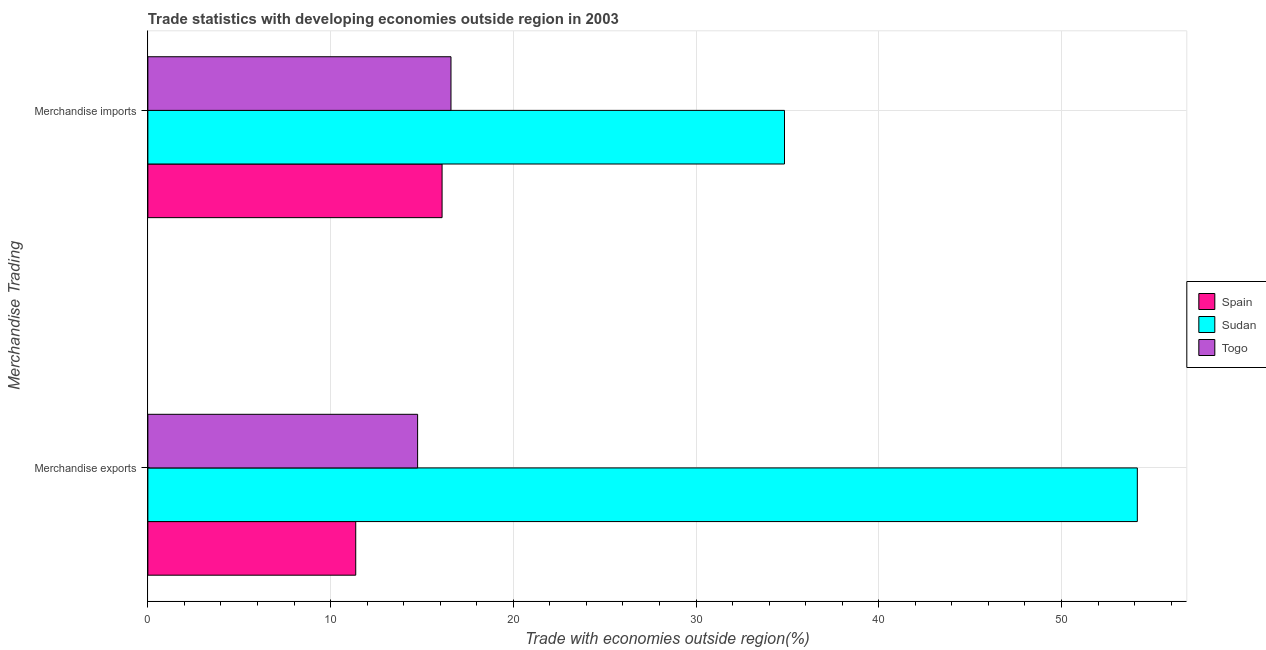How many different coloured bars are there?
Keep it short and to the point. 3. How many groups of bars are there?
Your answer should be compact. 2. How many bars are there on the 1st tick from the bottom?
Provide a short and direct response. 3. What is the label of the 1st group of bars from the top?
Provide a short and direct response. Merchandise imports. What is the merchandise imports in Spain?
Your response must be concise. 16.1. Across all countries, what is the maximum merchandise exports?
Provide a succinct answer. 54.15. Across all countries, what is the minimum merchandise exports?
Your response must be concise. 11.38. In which country was the merchandise imports maximum?
Make the answer very short. Sudan. What is the total merchandise imports in the graph?
Provide a short and direct response. 67.53. What is the difference between the merchandise exports in Spain and that in Togo?
Give a very brief answer. -3.39. What is the difference between the merchandise exports in Spain and the merchandise imports in Togo?
Ensure brevity in your answer.  -5.21. What is the average merchandise imports per country?
Keep it short and to the point. 22.51. What is the difference between the merchandise exports and merchandise imports in Spain?
Give a very brief answer. -4.73. In how many countries, is the merchandise exports greater than 20 %?
Offer a terse response. 1. What is the ratio of the merchandise exports in Togo to that in Spain?
Keep it short and to the point. 1.3. In how many countries, is the merchandise exports greater than the average merchandise exports taken over all countries?
Offer a very short reply. 1. What does the 2nd bar from the top in Merchandise imports represents?
Give a very brief answer. Sudan. What does the 3rd bar from the bottom in Merchandise exports represents?
Make the answer very short. Togo. How many bars are there?
Provide a succinct answer. 6. Are all the bars in the graph horizontal?
Give a very brief answer. Yes. What is the difference between two consecutive major ticks on the X-axis?
Offer a terse response. 10. Does the graph contain grids?
Offer a terse response. Yes. Where does the legend appear in the graph?
Provide a short and direct response. Center right. How many legend labels are there?
Ensure brevity in your answer.  3. How are the legend labels stacked?
Offer a terse response. Vertical. What is the title of the graph?
Offer a terse response. Trade statistics with developing economies outside region in 2003. Does "Finland" appear as one of the legend labels in the graph?
Ensure brevity in your answer.  No. What is the label or title of the X-axis?
Provide a succinct answer. Trade with economies outside region(%). What is the label or title of the Y-axis?
Give a very brief answer. Merchandise Trading. What is the Trade with economies outside region(%) of Spain in Merchandise exports?
Your response must be concise. 11.38. What is the Trade with economies outside region(%) in Sudan in Merchandise exports?
Give a very brief answer. 54.15. What is the Trade with economies outside region(%) in Togo in Merchandise exports?
Offer a very short reply. 14.76. What is the Trade with economies outside region(%) of Spain in Merchandise imports?
Offer a very short reply. 16.1. What is the Trade with economies outside region(%) of Sudan in Merchandise imports?
Your response must be concise. 34.84. What is the Trade with economies outside region(%) in Togo in Merchandise imports?
Your answer should be compact. 16.59. Across all Merchandise Trading, what is the maximum Trade with economies outside region(%) in Spain?
Ensure brevity in your answer.  16.1. Across all Merchandise Trading, what is the maximum Trade with economies outside region(%) in Sudan?
Offer a terse response. 54.15. Across all Merchandise Trading, what is the maximum Trade with economies outside region(%) in Togo?
Give a very brief answer. 16.59. Across all Merchandise Trading, what is the minimum Trade with economies outside region(%) in Spain?
Offer a very short reply. 11.38. Across all Merchandise Trading, what is the minimum Trade with economies outside region(%) in Sudan?
Your answer should be very brief. 34.84. Across all Merchandise Trading, what is the minimum Trade with economies outside region(%) in Togo?
Make the answer very short. 14.76. What is the total Trade with economies outside region(%) of Spain in the graph?
Your answer should be compact. 27.48. What is the total Trade with economies outside region(%) in Sudan in the graph?
Offer a terse response. 88.99. What is the total Trade with economies outside region(%) of Togo in the graph?
Your answer should be very brief. 31.35. What is the difference between the Trade with economies outside region(%) of Spain in Merchandise exports and that in Merchandise imports?
Keep it short and to the point. -4.73. What is the difference between the Trade with economies outside region(%) of Sudan in Merchandise exports and that in Merchandise imports?
Offer a very short reply. 19.31. What is the difference between the Trade with economies outside region(%) in Togo in Merchandise exports and that in Merchandise imports?
Keep it short and to the point. -1.83. What is the difference between the Trade with economies outside region(%) of Spain in Merchandise exports and the Trade with economies outside region(%) of Sudan in Merchandise imports?
Provide a succinct answer. -23.47. What is the difference between the Trade with economies outside region(%) of Spain in Merchandise exports and the Trade with economies outside region(%) of Togo in Merchandise imports?
Your answer should be compact. -5.21. What is the difference between the Trade with economies outside region(%) in Sudan in Merchandise exports and the Trade with economies outside region(%) in Togo in Merchandise imports?
Ensure brevity in your answer.  37.56. What is the average Trade with economies outside region(%) of Spain per Merchandise Trading?
Provide a short and direct response. 13.74. What is the average Trade with economies outside region(%) in Sudan per Merchandise Trading?
Keep it short and to the point. 44.5. What is the average Trade with economies outside region(%) of Togo per Merchandise Trading?
Ensure brevity in your answer.  15.68. What is the difference between the Trade with economies outside region(%) in Spain and Trade with economies outside region(%) in Sudan in Merchandise exports?
Keep it short and to the point. -42.77. What is the difference between the Trade with economies outside region(%) in Spain and Trade with economies outside region(%) in Togo in Merchandise exports?
Give a very brief answer. -3.39. What is the difference between the Trade with economies outside region(%) of Sudan and Trade with economies outside region(%) of Togo in Merchandise exports?
Provide a short and direct response. 39.39. What is the difference between the Trade with economies outside region(%) in Spain and Trade with economies outside region(%) in Sudan in Merchandise imports?
Give a very brief answer. -18.74. What is the difference between the Trade with economies outside region(%) in Spain and Trade with economies outside region(%) in Togo in Merchandise imports?
Your answer should be very brief. -0.49. What is the difference between the Trade with economies outside region(%) in Sudan and Trade with economies outside region(%) in Togo in Merchandise imports?
Your response must be concise. 18.25. What is the ratio of the Trade with economies outside region(%) in Spain in Merchandise exports to that in Merchandise imports?
Provide a succinct answer. 0.71. What is the ratio of the Trade with economies outside region(%) of Sudan in Merchandise exports to that in Merchandise imports?
Offer a terse response. 1.55. What is the ratio of the Trade with economies outside region(%) in Togo in Merchandise exports to that in Merchandise imports?
Provide a succinct answer. 0.89. What is the difference between the highest and the second highest Trade with economies outside region(%) of Spain?
Offer a terse response. 4.73. What is the difference between the highest and the second highest Trade with economies outside region(%) of Sudan?
Keep it short and to the point. 19.31. What is the difference between the highest and the second highest Trade with economies outside region(%) of Togo?
Offer a very short reply. 1.83. What is the difference between the highest and the lowest Trade with economies outside region(%) in Spain?
Give a very brief answer. 4.73. What is the difference between the highest and the lowest Trade with economies outside region(%) of Sudan?
Offer a very short reply. 19.31. What is the difference between the highest and the lowest Trade with economies outside region(%) of Togo?
Offer a terse response. 1.83. 